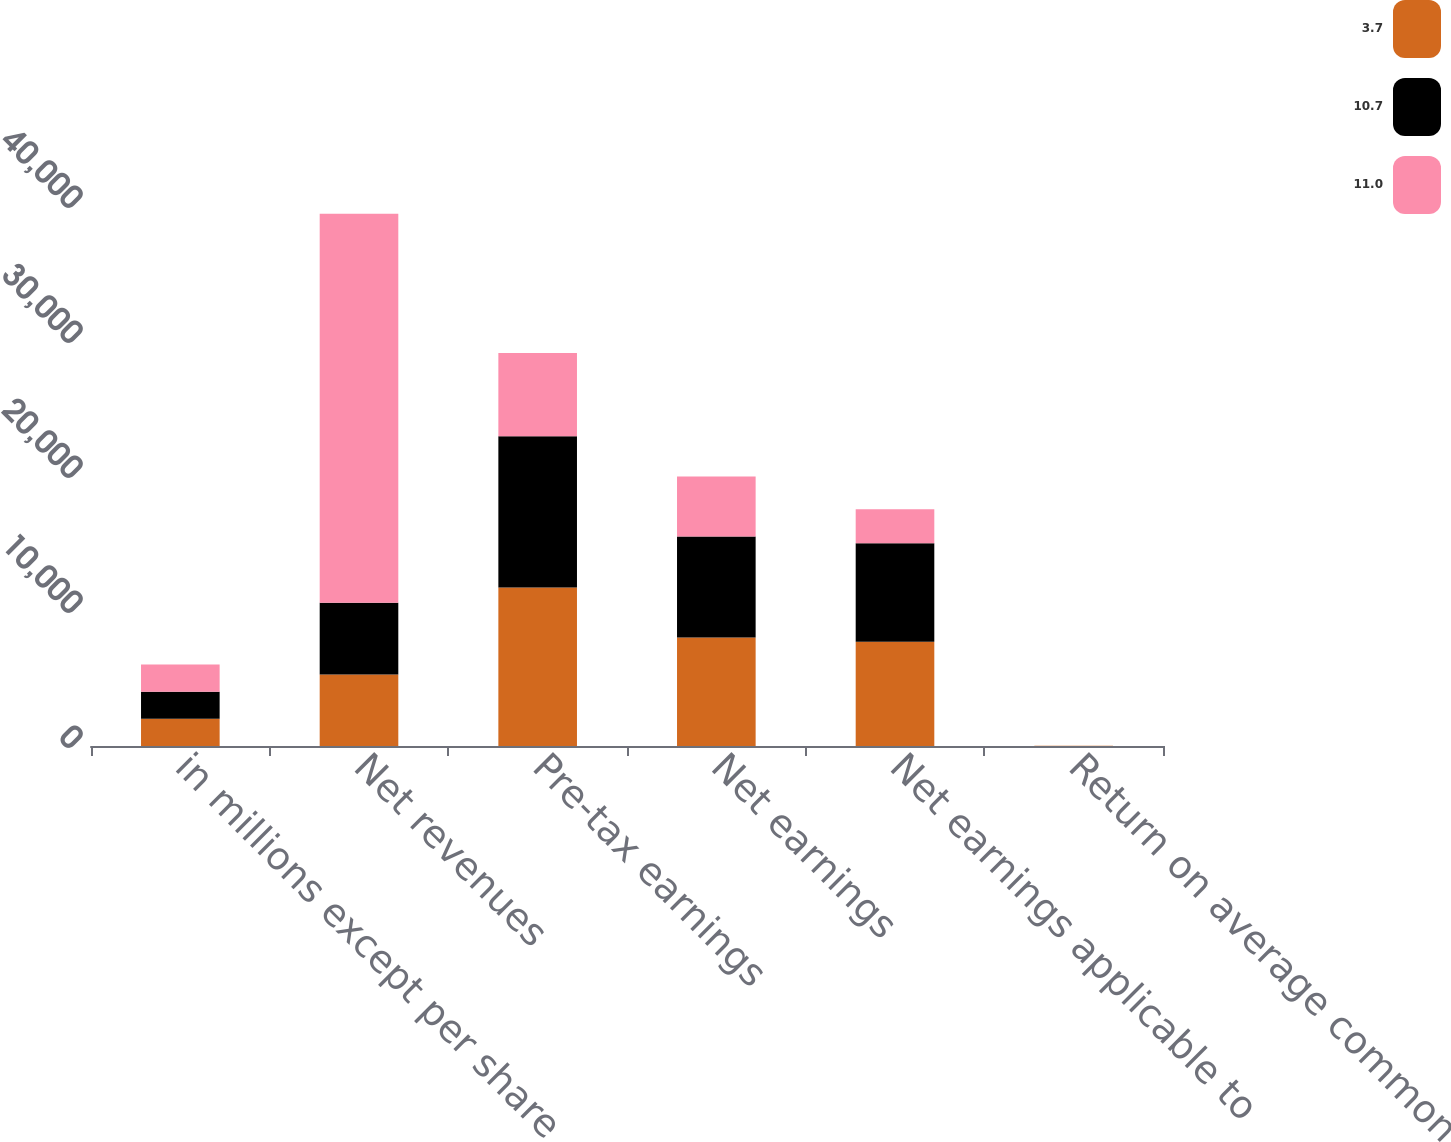Convert chart. <chart><loc_0><loc_0><loc_500><loc_500><stacked_bar_chart><ecel><fcel>in millions except per share<fcel>Net revenues<fcel>Pre-tax earnings<fcel>Net earnings<fcel>Net earnings applicable to<fcel>Return on average common<nl><fcel>3.7<fcel>2013<fcel>5305.5<fcel>11737<fcel>8040<fcel>7726<fcel>11<nl><fcel>10.7<fcel>2012<fcel>5305.5<fcel>11207<fcel>7475<fcel>7292<fcel>10.7<nl><fcel>11<fcel>2011<fcel>28811<fcel>6169<fcel>4442<fcel>2510<fcel>3.7<nl></chart> 